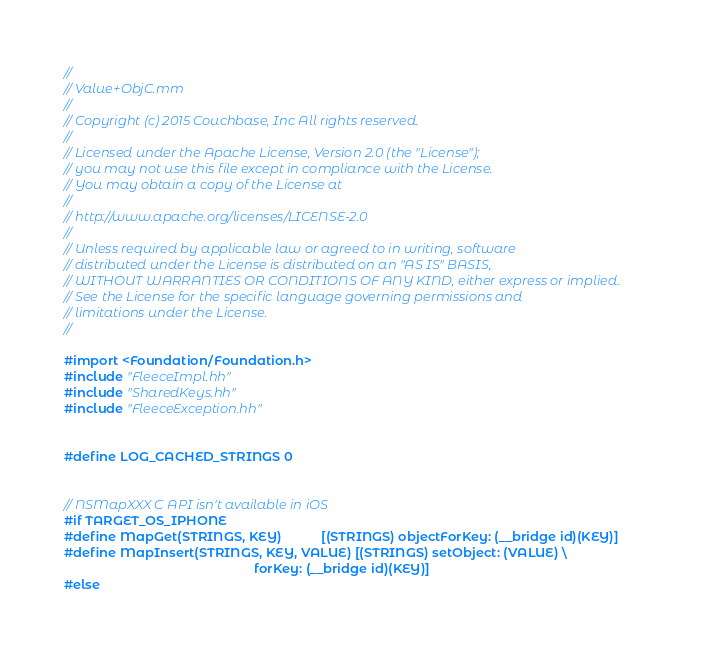<code> <loc_0><loc_0><loc_500><loc_500><_ObjectiveC_>//
// Value+ObjC.mm
//
// Copyright (c) 2015 Couchbase, Inc All rights reserved.
//
// Licensed under the Apache License, Version 2.0 (the "License");
// you may not use this file except in compliance with the License.
// You may obtain a copy of the License at
//
// http://www.apache.org/licenses/LICENSE-2.0
//
// Unless required by applicable law or agreed to in writing, software
// distributed under the License is distributed on an "AS IS" BASIS,
// WITHOUT WARRANTIES OR CONDITIONS OF ANY KIND, either express or implied.
// See the License for the specific language governing permissions and
// limitations under the License.
//

#import <Foundation/Foundation.h>
#include "FleeceImpl.hh"
#include "SharedKeys.hh"
#include "FleeceException.hh"


#define LOG_CACHED_STRINGS 0


// NSMapXXX C API isn't available in iOS
#if TARGET_OS_IPHONE
#define MapGet(STRINGS, KEY)           [(STRINGS) objectForKey: (__bridge id)(KEY)]
#define MapInsert(STRINGS, KEY, VALUE) [(STRINGS) setObject: (VALUE) \
                                                     forKey: (__bridge id)(KEY)]
#else</code> 